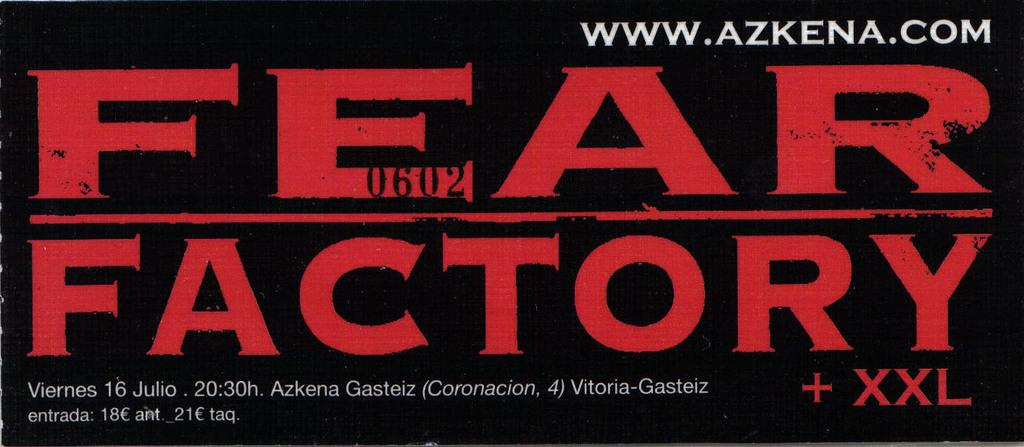<image>
Present a compact description of the photo's key features. An Advertisement for Fear Factory written in red with www.azkena.com written in white above it. 